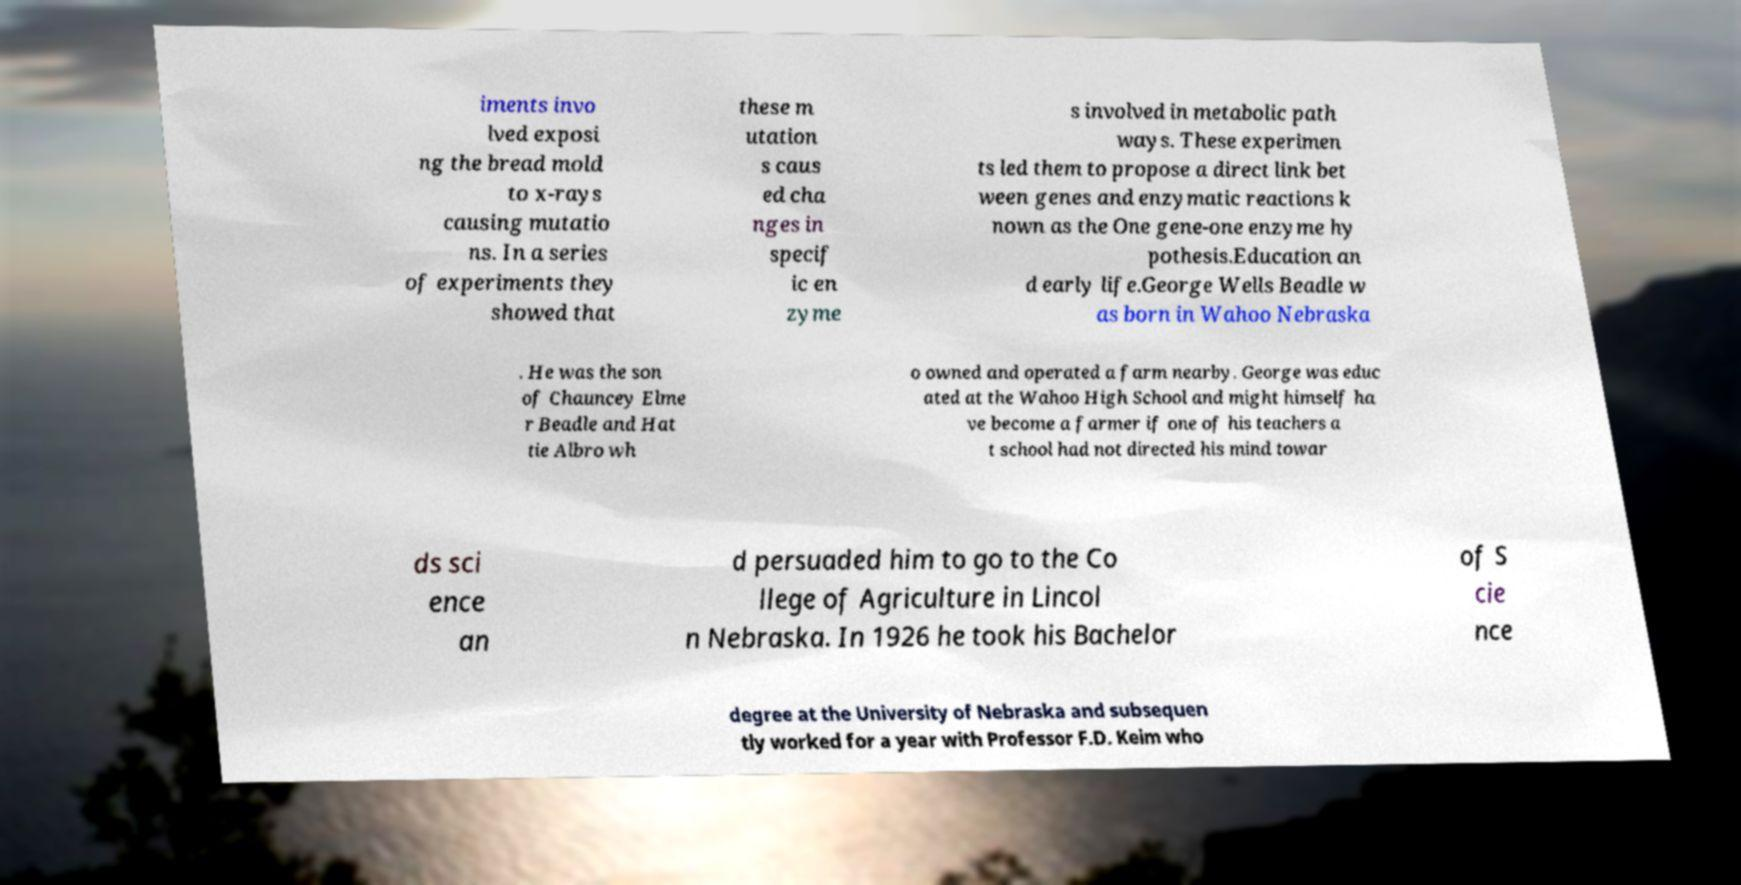Could you extract and type out the text from this image? iments invo lved exposi ng the bread mold to x-rays causing mutatio ns. In a series of experiments they showed that these m utation s caus ed cha nges in specif ic en zyme s involved in metabolic path ways. These experimen ts led them to propose a direct link bet ween genes and enzymatic reactions k nown as the One gene-one enzyme hy pothesis.Education an d early life.George Wells Beadle w as born in Wahoo Nebraska . He was the son of Chauncey Elme r Beadle and Hat tie Albro wh o owned and operated a farm nearby. George was educ ated at the Wahoo High School and might himself ha ve become a farmer if one of his teachers a t school had not directed his mind towar ds sci ence an d persuaded him to go to the Co llege of Agriculture in Lincol n Nebraska. In 1926 he took his Bachelor of S cie nce degree at the University of Nebraska and subsequen tly worked for a year with Professor F.D. Keim who 